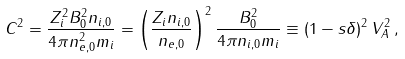Convert formula to latex. <formula><loc_0><loc_0><loc_500><loc_500>C ^ { 2 } = \frac { Z _ { i } ^ { 2 } B _ { 0 } ^ { 2 } n _ { i , 0 } } { 4 \pi n _ { e , 0 } ^ { 2 } m _ { i } } = \left ( \frac { Z _ { i } n _ { i , 0 } } { n _ { e , 0 } } \right ) ^ { 2 } \frac { B _ { 0 } ^ { 2 } } { 4 \pi n _ { i , 0 } m _ { i } } \equiv ( 1 - s \delta ) ^ { 2 } \, V _ { A } ^ { 2 } \, ,</formula> 